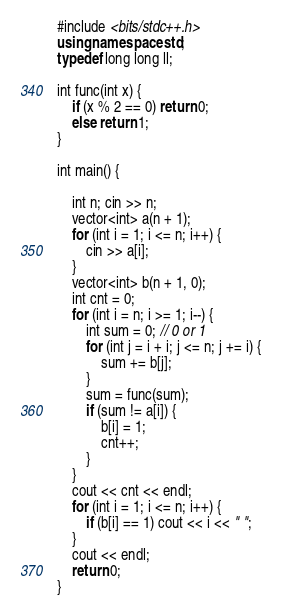Convert code to text. <code><loc_0><loc_0><loc_500><loc_500><_C++_>#include <bits/stdc++.h>
using namespace std;
typedef long long ll;

int func(int x) {
	if (x % 2 == 0) return 0;
	else return 1;
}

int main() {

	int n; cin >> n;
	vector<int> a(n + 1);
	for (int i = 1; i <= n; i++) {
		cin >> a[i];
	}
	vector<int> b(n + 1, 0);
	int cnt = 0;
	for (int i = n; i >= 1; i--) {
		int sum = 0; // 0 or 1
		for (int j = i + i; j <= n; j += i) {
			sum += b[j];
		}
		sum = func(sum);
		if (sum != a[i]) {
			b[i] = 1;
			cnt++;
		}
	}
	cout << cnt << endl;
	for (int i = 1; i <= n; i++) {
		if (b[i] == 1) cout << i << " ";
	}
	cout << endl;
	return 0;
}</code> 